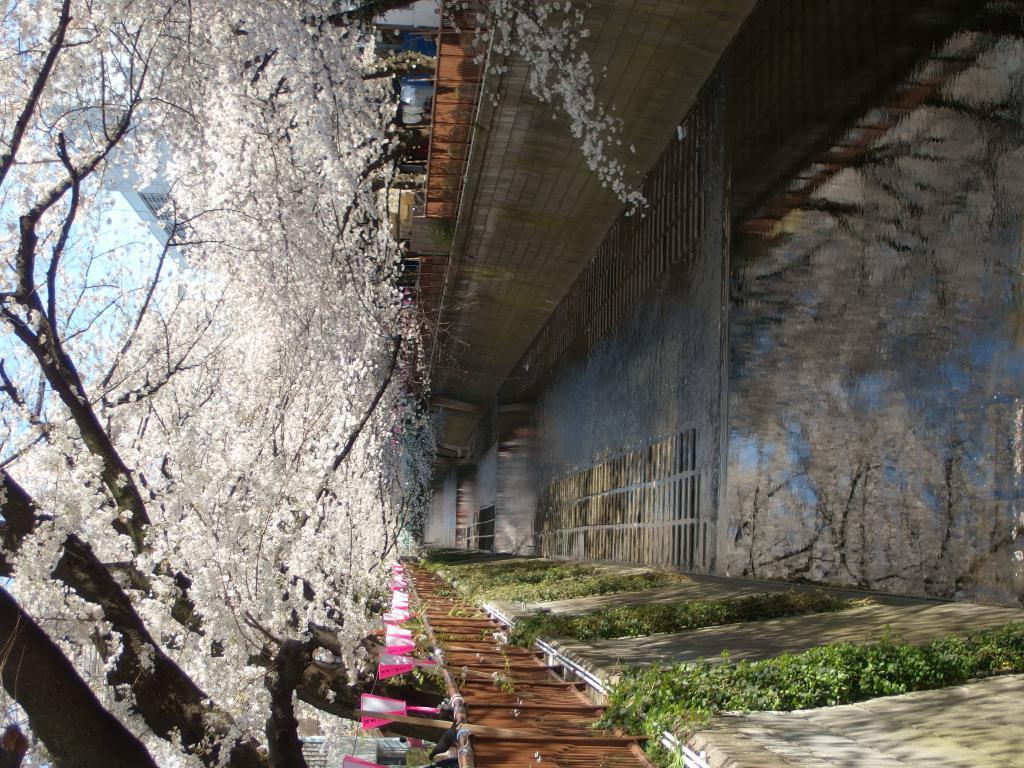Please provide a concise description of this image. In this image I can see the building, railing and the trees. In the background I can see the sky. 